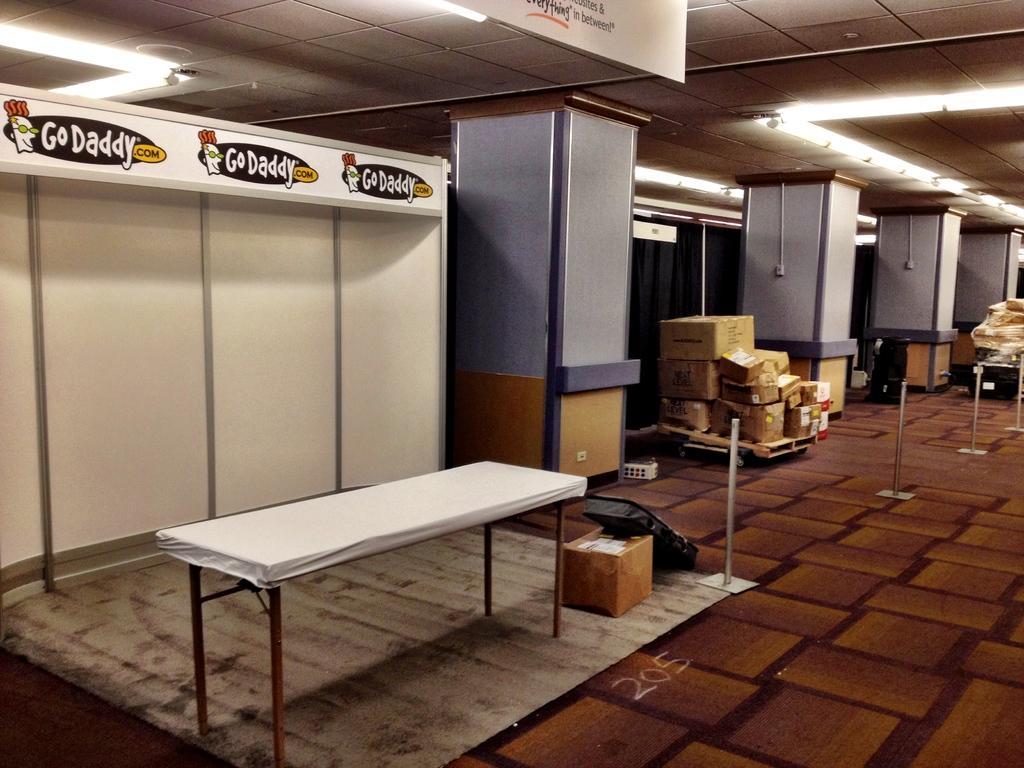Could you give a brief overview of what you see in this image? On the left side, there is a table which is covered with white color cloth. Beside this table, there is a box and an object on the floor and there is a hoarding attached to the wall. In the background, there are pillars, there are lights attached to the roof and there are poles. 